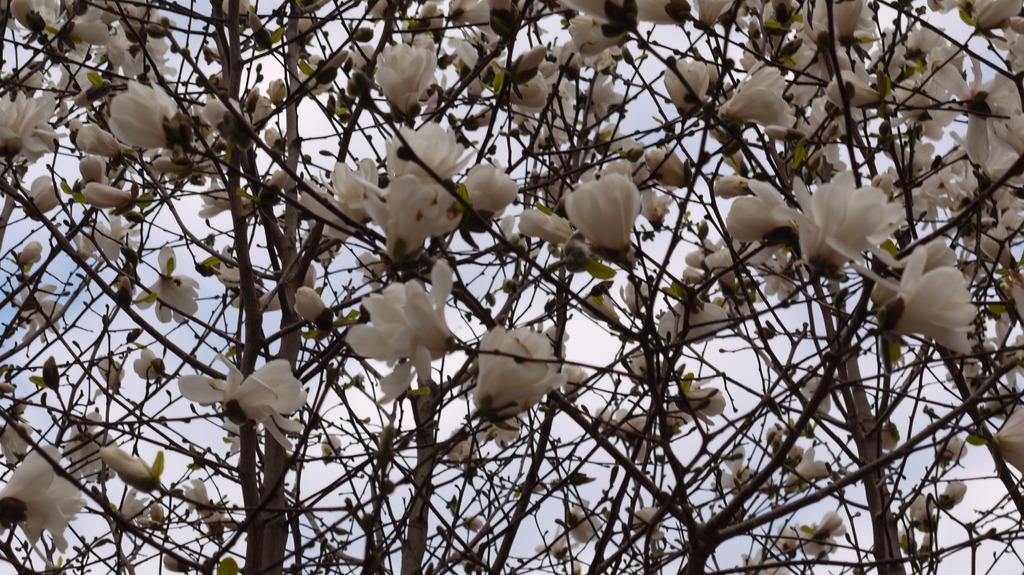What is the main subject of the image? The main subject of the image is branches with flowers. What can be seen in the background of the image? The sky is visible in the background of the image. Are there any weather-related elements in the background? Yes, clouds are present in the background of the image. What type of air can be seen coming out of the flowers in the image? There is no air coming out of the flowers in the image. 